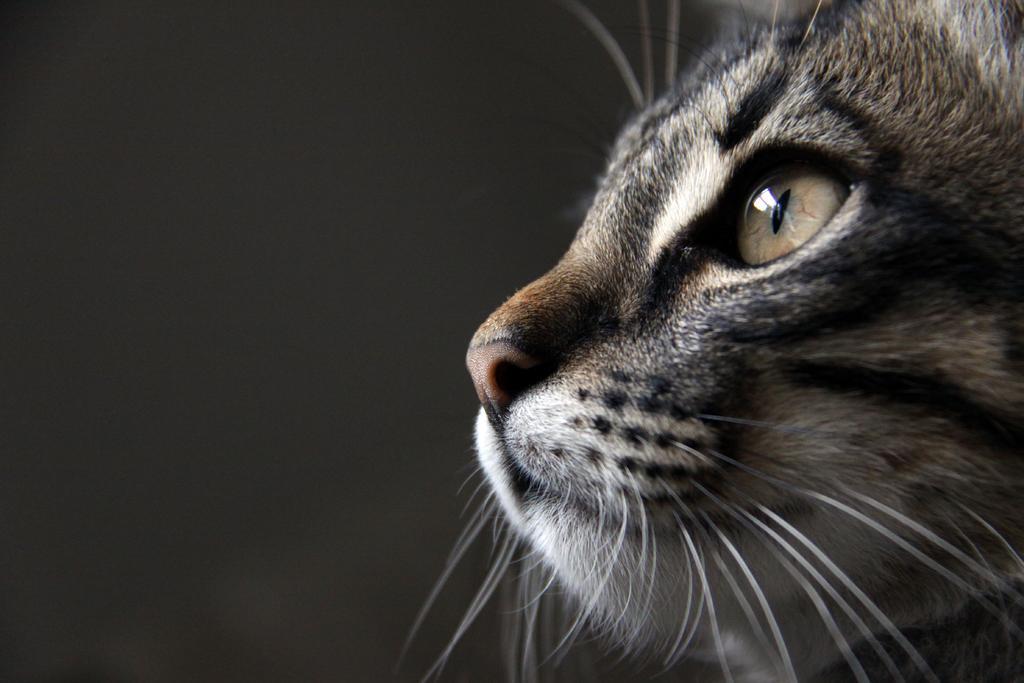In one or two sentences, can you explain what this image depicts? In the picture we can see part of the cat face with mustache, eye and nose. 